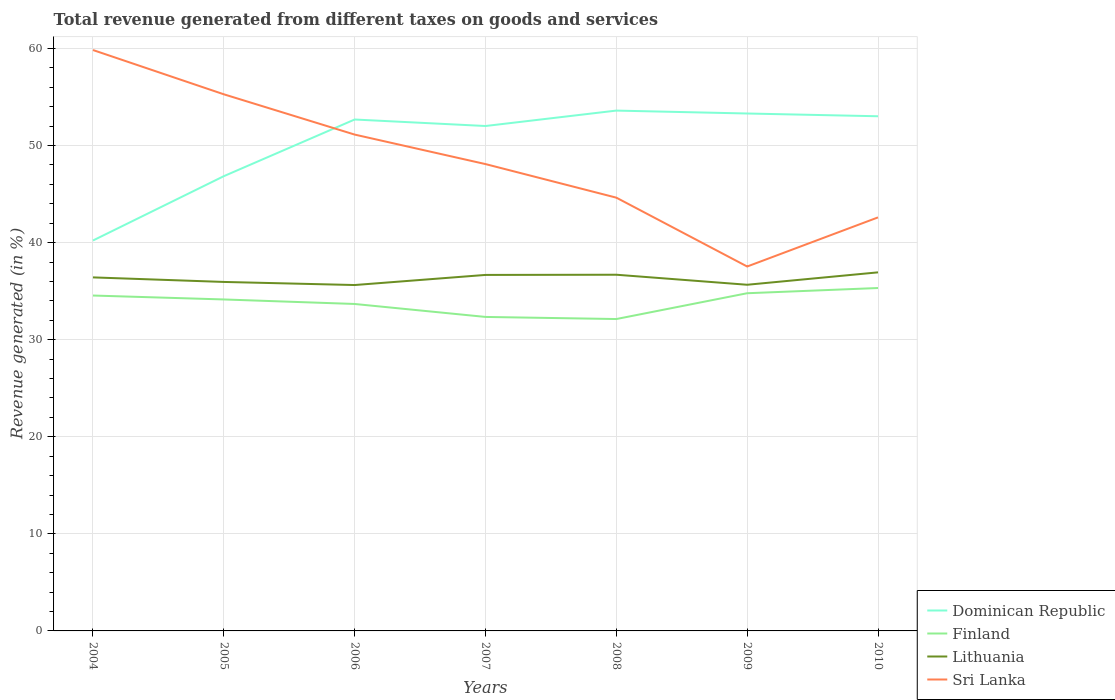How many different coloured lines are there?
Ensure brevity in your answer.  4. Does the line corresponding to Lithuania intersect with the line corresponding to Sri Lanka?
Your answer should be very brief. No. Is the number of lines equal to the number of legend labels?
Keep it short and to the point. Yes. Across all years, what is the maximum total revenue generated in Finland?
Make the answer very short. 32.13. In which year was the total revenue generated in Lithuania maximum?
Provide a succinct answer. 2006. What is the total total revenue generated in Sri Lanka in the graph?
Your response must be concise. 17.24. What is the difference between the highest and the second highest total revenue generated in Finland?
Your answer should be compact. 3.2. Is the total revenue generated in Lithuania strictly greater than the total revenue generated in Sri Lanka over the years?
Offer a terse response. Yes. How many lines are there?
Give a very brief answer. 4. How many years are there in the graph?
Offer a terse response. 7. What is the difference between two consecutive major ticks on the Y-axis?
Provide a succinct answer. 10. Are the values on the major ticks of Y-axis written in scientific E-notation?
Provide a succinct answer. No. Does the graph contain grids?
Your response must be concise. Yes. Where does the legend appear in the graph?
Your answer should be compact. Bottom right. How are the legend labels stacked?
Make the answer very short. Vertical. What is the title of the graph?
Your answer should be compact. Total revenue generated from different taxes on goods and services. What is the label or title of the Y-axis?
Give a very brief answer. Revenue generated (in %). What is the Revenue generated (in %) of Dominican Republic in 2004?
Give a very brief answer. 40.22. What is the Revenue generated (in %) of Finland in 2004?
Your answer should be very brief. 34.55. What is the Revenue generated (in %) in Lithuania in 2004?
Give a very brief answer. 36.42. What is the Revenue generated (in %) of Sri Lanka in 2004?
Offer a terse response. 59.84. What is the Revenue generated (in %) of Dominican Republic in 2005?
Give a very brief answer. 46.85. What is the Revenue generated (in %) of Finland in 2005?
Your response must be concise. 34.15. What is the Revenue generated (in %) of Lithuania in 2005?
Make the answer very short. 35.95. What is the Revenue generated (in %) in Sri Lanka in 2005?
Provide a short and direct response. 55.28. What is the Revenue generated (in %) of Dominican Republic in 2006?
Your answer should be compact. 52.68. What is the Revenue generated (in %) of Finland in 2006?
Your answer should be compact. 33.68. What is the Revenue generated (in %) of Lithuania in 2006?
Make the answer very short. 35.63. What is the Revenue generated (in %) of Sri Lanka in 2006?
Make the answer very short. 51.13. What is the Revenue generated (in %) in Dominican Republic in 2007?
Your response must be concise. 52.02. What is the Revenue generated (in %) in Finland in 2007?
Keep it short and to the point. 32.35. What is the Revenue generated (in %) in Lithuania in 2007?
Your response must be concise. 36.67. What is the Revenue generated (in %) in Sri Lanka in 2007?
Offer a very short reply. 48.09. What is the Revenue generated (in %) in Dominican Republic in 2008?
Offer a terse response. 53.6. What is the Revenue generated (in %) in Finland in 2008?
Your answer should be compact. 32.13. What is the Revenue generated (in %) in Lithuania in 2008?
Make the answer very short. 36.69. What is the Revenue generated (in %) of Sri Lanka in 2008?
Your answer should be compact. 44.63. What is the Revenue generated (in %) in Dominican Republic in 2009?
Give a very brief answer. 53.3. What is the Revenue generated (in %) of Finland in 2009?
Offer a very short reply. 34.79. What is the Revenue generated (in %) in Lithuania in 2009?
Make the answer very short. 35.66. What is the Revenue generated (in %) of Sri Lanka in 2009?
Make the answer very short. 37.54. What is the Revenue generated (in %) of Dominican Republic in 2010?
Ensure brevity in your answer.  53.02. What is the Revenue generated (in %) of Finland in 2010?
Your answer should be compact. 35.33. What is the Revenue generated (in %) of Lithuania in 2010?
Offer a very short reply. 36.94. What is the Revenue generated (in %) of Sri Lanka in 2010?
Your response must be concise. 42.6. Across all years, what is the maximum Revenue generated (in %) of Dominican Republic?
Provide a short and direct response. 53.6. Across all years, what is the maximum Revenue generated (in %) of Finland?
Your answer should be very brief. 35.33. Across all years, what is the maximum Revenue generated (in %) in Lithuania?
Provide a short and direct response. 36.94. Across all years, what is the maximum Revenue generated (in %) in Sri Lanka?
Give a very brief answer. 59.84. Across all years, what is the minimum Revenue generated (in %) of Dominican Republic?
Offer a very short reply. 40.22. Across all years, what is the minimum Revenue generated (in %) of Finland?
Your answer should be compact. 32.13. Across all years, what is the minimum Revenue generated (in %) of Lithuania?
Your response must be concise. 35.63. Across all years, what is the minimum Revenue generated (in %) in Sri Lanka?
Your answer should be very brief. 37.54. What is the total Revenue generated (in %) of Dominican Republic in the graph?
Provide a short and direct response. 351.69. What is the total Revenue generated (in %) of Finland in the graph?
Make the answer very short. 236.97. What is the total Revenue generated (in %) of Lithuania in the graph?
Give a very brief answer. 253.97. What is the total Revenue generated (in %) in Sri Lanka in the graph?
Offer a terse response. 339.13. What is the difference between the Revenue generated (in %) in Dominican Republic in 2004 and that in 2005?
Provide a short and direct response. -6.63. What is the difference between the Revenue generated (in %) in Finland in 2004 and that in 2005?
Offer a very short reply. 0.4. What is the difference between the Revenue generated (in %) in Lithuania in 2004 and that in 2005?
Your answer should be very brief. 0.47. What is the difference between the Revenue generated (in %) in Sri Lanka in 2004 and that in 2005?
Your answer should be compact. 4.56. What is the difference between the Revenue generated (in %) of Dominican Republic in 2004 and that in 2006?
Your answer should be very brief. -12.47. What is the difference between the Revenue generated (in %) of Finland in 2004 and that in 2006?
Your response must be concise. 0.87. What is the difference between the Revenue generated (in %) in Lithuania in 2004 and that in 2006?
Give a very brief answer. 0.79. What is the difference between the Revenue generated (in %) in Sri Lanka in 2004 and that in 2006?
Your response must be concise. 8.71. What is the difference between the Revenue generated (in %) in Dominican Republic in 2004 and that in 2007?
Offer a terse response. -11.8. What is the difference between the Revenue generated (in %) of Finland in 2004 and that in 2007?
Provide a succinct answer. 2.2. What is the difference between the Revenue generated (in %) in Lithuania in 2004 and that in 2007?
Offer a very short reply. -0.25. What is the difference between the Revenue generated (in %) of Sri Lanka in 2004 and that in 2007?
Provide a succinct answer. 11.75. What is the difference between the Revenue generated (in %) of Dominican Republic in 2004 and that in 2008?
Keep it short and to the point. -13.38. What is the difference between the Revenue generated (in %) in Finland in 2004 and that in 2008?
Your answer should be very brief. 2.42. What is the difference between the Revenue generated (in %) of Lithuania in 2004 and that in 2008?
Give a very brief answer. -0.27. What is the difference between the Revenue generated (in %) of Sri Lanka in 2004 and that in 2008?
Your response must be concise. 15.21. What is the difference between the Revenue generated (in %) of Dominican Republic in 2004 and that in 2009?
Make the answer very short. -13.08. What is the difference between the Revenue generated (in %) of Finland in 2004 and that in 2009?
Your answer should be very brief. -0.24. What is the difference between the Revenue generated (in %) in Lithuania in 2004 and that in 2009?
Your response must be concise. 0.76. What is the difference between the Revenue generated (in %) in Sri Lanka in 2004 and that in 2009?
Ensure brevity in your answer.  22.3. What is the difference between the Revenue generated (in %) of Finland in 2004 and that in 2010?
Provide a succinct answer. -0.78. What is the difference between the Revenue generated (in %) in Lithuania in 2004 and that in 2010?
Ensure brevity in your answer.  -0.52. What is the difference between the Revenue generated (in %) in Sri Lanka in 2004 and that in 2010?
Your answer should be very brief. 17.24. What is the difference between the Revenue generated (in %) in Dominican Republic in 2005 and that in 2006?
Offer a terse response. -5.84. What is the difference between the Revenue generated (in %) in Finland in 2005 and that in 2006?
Provide a short and direct response. 0.47. What is the difference between the Revenue generated (in %) in Lithuania in 2005 and that in 2006?
Your response must be concise. 0.32. What is the difference between the Revenue generated (in %) of Sri Lanka in 2005 and that in 2006?
Ensure brevity in your answer.  4.15. What is the difference between the Revenue generated (in %) of Dominican Republic in 2005 and that in 2007?
Your answer should be compact. -5.17. What is the difference between the Revenue generated (in %) in Finland in 2005 and that in 2007?
Your answer should be very brief. 1.8. What is the difference between the Revenue generated (in %) of Lithuania in 2005 and that in 2007?
Make the answer very short. -0.72. What is the difference between the Revenue generated (in %) of Sri Lanka in 2005 and that in 2007?
Your response must be concise. 7.19. What is the difference between the Revenue generated (in %) of Dominican Republic in 2005 and that in 2008?
Your response must be concise. -6.76. What is the difference between the Revenue generated (in %) in Finland in 2005 and that in 2008?
Ensure brevity in your answer.  2.02. What is the difference between the Revenue generated (in %) in Lithuania in 2005 and that in 2008?
Offer a terse response. -0.74. What is the difference between the Revenue generated (in %) of Sri Lanka in 2005 and that in 2008?
Offer a terse response. 10.65. What is the difference between the Revenue generated (in %) in Dominican Republic in 2005 and that in 2009?
Make the answer very short. -6.46. What is the difference between the Revenue generated (in %) of Finland in 2005 and that in 2009?
Offer a very short reply. -0.64. What is the difference between the Revenue generated (in %) in Lithuania in 2005 and that in 2009?
Keep it short and to the point. 0.29. What is the difference between the Revenue generated (in %) of Sri Lanka in 2005 and that in 2009?
Offer a terse response. 17.74. What is the difference between the Revenue generated (in %) of Dominican Republic in 2005 and that in 2010?
Provide a short and direct response. -6.17. What is the difference between the Revenue generated (in %) of Finland in 2005 and that in 2010?
Make the answer very short. -1.18. What is the difference between the Revenue generated (in %) in Lithuania in 2005 and that in 2010?
Your response must be concise. -0.99. What is the difference between the Revenue generated (in %) in Sri Lanka in 2005 and that in 2010?
Offer a very short reply. 12.68. What is the difference between the Revenue generated (in %) of Dominican Republic in 2006 and that in 2007?
Give a very brief answer. 0.67. What is the difference between the Revenue generated (in %) in Finland in 2006 and that in 2007?
Offer a terse response. 1.33. What is the difference between the Revenue generated (in %) of Lithuania in 2006 and that in 2007?
Offer a terse response. -1.04. What is the difference between the Revenue generated (in %) of Sri Lanka in 2006 and that in 2007?
Offer a very short reply. 3.04. What is the difference between the Revenue generated (in %) in Dominican Republic in 2006 and that in 2008?
Give a very brief answer. -0.92. What is the difference between the Revenue generated (in %) of Finland in 2006 and that in 2008?
Your response must be concise. 1.55. What is the difference between the Revenue generated (in %) of Lithuania in 2006 and that in 2008?
Your response must be concise. -1.06. What is the difference between the Revenue generated (in %) of Sri Lanka in 2006 and that in 2008?
Offer a terse response. 6.5. What is the difference between the Revenue generated (in %) of Dominican Republic in 2006 and that in 2009?
Give a very brief answer. -0.62. What is the difference between the Revenue generated (in %) in Finland in 2006 and that in 2009?
Provide a succinct answer. -1.11. What is the difference between the Revenue generated (in %) of Lithuania in 2006 and that in 2009?
Your response must be concise. -0.03. What is the difference between the Revenue generated (in %) in Sri Lanka in 2006 and that in 2009?
Ensure brevity in your answer.  13.59. What is the difference between the Revenue generated (in %) of Dominican Republic in 2006 and that in 2010?
Provide a succinct answer. -0.33. What is the difference between the Revenue generated (in %) of Finland in 2006 and that in 2010?
Your answer should be compact. -1.64. What is the difference between the Revenue generated (in %) in Lithuania in 2006 and that in 2010?
Offer a terse response. -1.31. What is the difference between the Revenue generated (in %) of Sri Lanka in 2006 and that in 2010?
Keep it short and to the point. 8.53. What is the difference between the Revenue generated (in %) in Dominican Republic in 2007 and that in 2008?
Ensure brevity in your answer.  -1.59. What is the difference between the Revenue generated (in %) in Finland in 2007 and that in 2008?
Ensure brevity in your answer.  0.22. What is the difference between the Revenue generated (in %) in Lithuania in 2007 and that in 2008?
Your response must be concise. -0.02. What is the difference between the Revenue generated (in %) of Sri Lanka in 2007 and that in 2008?
Make the answer very short. 3.46. What is the difference between the Revenue generated (in %) in Dominican Republic in 2007 and that in 2009?
Make the answer very short. -1.29. What is the difference between the Revenue generated (in %) of Finland in 2007 and that in 2009?
Your response must be concise. -2.44. What is the difference between the Revenue generated (in %) in Lithuania in 2007 and that in 2009?
Make the answer very short. 1.01. What is the difference between the Revenue generated (in %) of Sri Lanka in 2007 and that in 2009?
Provide a succinct answer. 10.55. What is the difference between the Revenue generated (in %) of Dominican Republic in 2007 and that in 2010?
Provide a succinct answer. -1. What is the difference between the Revenue generated (in %) in Finland in 2007 and that in 2010?
Offer a very short reply. -2.98. What is the difference between the Revenue generated (in %) in Lithuania in 2007 and that in 2010?
Your response must be concise. -0.26. What is the difference between the Revenue generated (in %) of Sri Lanka in 2007 and that in 2010?
Ensure brevity in your answer.  5.49. What is the difference between the Revenue generated (in %) of Dominican Republic in 2008 and that in 2009?
Offer a terse response. 0.3. What is the difference between the Revenue generated (in %) of Finland in 2008 and that in 2009?
Give a very brief answer. -2.66. What is the difference between the Revenue generated (in %) of Lithuania in 2008 and that in 2009?
Your response must be concise. 1.03. What is the difference between the Revenue generated (in %) in Sri Lanka in 2008 and that in 2009?
Offer a very short reply. 7.09. What is the difference between the Revenue generated (in %) of Dominican Republic in 2008 and that in 2010?
Your response must be concise. 0.58. What is the difference between the Revenue generated (in %) in Finland in 2008 and that in 2010?
Offer a very short reply. -3.2. What is the difference between the Revenue generated (in %) in Lithuania in 2008 and that in 2010?
Ensure brevity in your answer.  -0.24. What is the difference between the Revenue generated (in %) of Sri Lanka in 2008 and that in 2010?
Your response must be concise. 2.03. What is the difference between the Revenue generated (in %) in Dominican Republic in 2009 and that in 2010?
Provide a short and direct response. 0.28. What is the difference between the Revenue generated (in %) of Finland in 2009 and that in 2010?
Provide a succinct answer. -0.54. What is the difference between the Revenue generated (in %) in Lithuania in 2009 and that in 2010?
Ensure brevity in your answer.  -1.28. What is the difference between the Revenue generated (in %) in Sri Lanka in 2009 and that in 2010?
Provide a short and direct response. -5.06. What is the difference between the Revenue generated (in %) in Dominican Republic in 2004 and the Revenue generated (in %) in Finland in 2005?
Keep it short and to the point. 6.07. What is the difference between the Revenue generated (in %) in Dominican Republic in 2004 and the Revenue generated (in %) in Lithuania in 2005?
Provide a short and direct response. 4.27. What is the difference between the Revenue generated (in %) in Dominican Republic in 2004 and the Revenue generated (in %) in Sri Lanka in 2005?
Your answer should be very brief. -15.06. What is the difference between the Revenue generated (in %) in Finland in 2004 and the Revenue generated (in %) in Lithuania in 2005?
Keep it short and to the point. -1.4. What is the difference between the Revenue generated (in %) of Finland in 2004 and the Revenue generated (in %) of Sri Lanka in 2005?
Your answer should be compact. -20.73. What is the difference between the Revenue generated (in %) of Lithuania in 2004 and the Revenue generated (in %) of Sri Lanka in 2005?
Offer a terse response. -18.86. What is the difference between the Revenue generated (in %) of Dominican Republic in 2004 and the Revenue generated (in %) of Finland in 2006?
Make the answer very short. 6.54. What is the difference between the Revenue generated (in %) in Dominican Republic in 2004 and the Revenue generated (in %) in Lithuania in 2006?
Provide a short and direct response. 4.59. What is the difference between the Revenue generated (in %) of Dominican Republic in 2004 and the Revenue generated (in %) of Sri Lanka in 2006?
Provide a succinct answer. -10.91. What is the difference between the Revenue generated (in %) in Finland in 2004 and the Revenue generated (in %) in Lithuania in 2006?
Keep it short and to the point. -1.08. What is the difference between the Revenue generated (in %) in Finland in 2004 and the Revenue generated (in %) in Sri Lanka in 2006?
Provide a short and direct response. -16.58. What is the difference between the Revenue generated (in %) of Lithuania in 2004 and the Revenue generated (in %) of Sri Lanka in 2006?
Keep it short and to the point. -14.71. What is the difference between the Revenue generated (in %) in Dominican Republic in 2004 and the Revenue generated (in %) in Finland in 2007?
Your response must be concise. 7.87. What is the difference between the Revenue generated (in %) of Dominican Republic in 2004 and the Revenue generated (in %) of Lithuania in 2007?
Offer a terse response. 3.54. What is the difference between the Revenue generated (in %) of Dominican Republic in 2004 and the Revenue generated (in %) of Sri Lanka in 2007?
Ensure brevity in your answer.  -7.87. What is the difference between the Revenue generated (in %) in Finland in 2004 and the Revenue generated (in %) in Lithuania in 2007?
Provide a short and direct response. -2.12. What is the difference between the Revenue generated (in %) of Finland in 2004 and the Revenue generated (in %) of Sri Lanka in 2007?
Your response must be concise. -13.54. What is the difference between the Revenue generated (in %) in Lithuania in 2004 and the Revenue generated (in %) in Sri Lanka in 2007?
Your answer should be very brief. -11.67. What is the difference between the Revenue generated (in %) of Dominican Republic in 2004 and the Revenue generated (in %) of Finland in 2008?
Your response must be concise. 8.09. What is the difference between the Revenue generated (in %) of Dominican Republic in 2004 and the Revenue generated (in %) of Lithuania in 2008?
Keep it short and to the point. 3.53. What is the difference between the Revenue generated (in %) in Dominican Republic in 2004 and the Revenue generated (in %) in Sri Lanka in 2008?
Give a very brief answer. -4.42. What is the difference between the Revenue generated (in %) of Finland in 2004 and the Revenue generated (in %) of Lithuania in 2008?
Your response must be concise. -2.14. What is the difference between the Revenue generated (in %) of Finland in 2004 and the Revenue generated (in %) of Sri Lanka in 2008?
Offer a terse response. -10.08. What is the difference between the Revenue generated (in %) in Lithuania in 2004 and the Revenue generated (in %) in Sri Lanka in 2008?
Your answer should be very brief. -8.21. What is the difference between the Revenue generated (in %) of Dominican Republic in 2004 and the Revenue generated (in %) of Finland in 2009?
Your response must be concise. 5.43. What is the difference between the Revenue generated (in %) in Dominican Republic in 2004 and the Revenue generated (in %) in Lithuania in 2009?
Make the answer very short. 4.56. What is the difference between the Revenue generated (in %) in Dominican Republic in 2004 and the Revenue generated (in %) in Sri Lanka in 2009?
Your answer should be compact. 2.68. What is the difference between the Revenue generated (in %) in Finland in 2004 and the Revenue generated (in %) in Lithuania in 2009?
Offer a terse response. -1.11. What is the difference between the Revenue generated (in %) of Finland in 2004 and the Revenue generated (in %) of Sri Lanka in 2009?
Make the answer very short. -2.99. What is the difference between the Revenue generated (in %) of Lithuania in 2004 and the Revenue generated (in %) of Sri Lanka in 2009?
Offer a terse response. -1.12. What is the difference between the Revenue generated (in %) of Dominican Republic in 2004 and the Revenue generated (in %) of Finland in 2010?
Your answer should be very brief. 4.89. What is the difference between the Revenue generated (in %) of Dominican Republic in 2004 and the Revenue generated (in %) of Lithuania in 2010?
Keep it short and to the point. 3.28. What is the difference between the Revenue generated (in %) of Dominican Republic in 2004 and the Revenue generated (in %) of Sri Lanka in 2010?
Offer a very short reply. -2.38. What is the difference between the Revenue generated (in %) in Finland in 2004 and the Revenue generated (in %) in Lithuania in 2010?
Offer a terse response. -2.39. What is the difference between the Revenue generated (in %) of Finland in 2004 and the Revenue generated (in %) of Sri Lanka in 2010?
Keep it short and to the point. -8.05. What is the difference between the Revenue generated (in %) in Lithuania in 2004 and the Revenue generated (in %) in Sri Lanka in 2010?
Your response must be concise. -6.18. What is the difference between the Revenue generated (in %) of Dominican Republic in 2005 and the Revenue generated (in %) of Finland in 2006?
Provide a succinct answer. 13.17. What is the difference between the Revenue generated (in %) in Dominican Republic in 2005 and the Revenue generated (in %) in Lithuania in 2006?
Your answer should be compact. 11.21. What is the difference between the Revenue generated (in %) of Dominican Republic in 2005 and the Revenue generated (in %) of Sri Lanka in 2006?
Your response must be concise. -4.29. What is the difference between the Revenue generated (in %) in Finland in 2005 and the Revenue generated (in %) in Lithuania in 2006?
Offer a very short reply. -1.49. What is the difference between the Revenue generated (in %) in Finland in 2005 and the Revenue generated (in %) in Sri Lanka in 2006?
Provide a succinct answer. -16.98. What is the difference between the Revenue generated (in %) of Lithuania in 2005 and the Revenue generated (in %) of Sri Lanka in 2006?
Your answer should be very brief. -15.18. What is the difference between the Revenue generated (in %) of Dominican Republic in 2005 and the Revenue generated (in %) of Finland in 2007?
Provide a short and direct response. 14.5. What is the difference between the Revenue generated (in %) in Dominican Republic in 2005 and the Revenue generated (in %) in Lithuania in 2007?
Offer a very short reply. 10.17. What is the difference between the Revenue generated (in %) in Dominican Republic in 2005 and the Revenue generated (in %) in Sri Lanka in 2007?
Make the answer very short. -1.25. What is the difference between the Revenue generated (in %) of Finland in 2005 and the Revenue generated (in %) of Lithuania in 2007?
Provide a succinct answer. -2.53. What is the difference between the Revenue generated (in %) in Finland in 2005 and the Revenue generated (in %) in Sri Lanka in 2007?
Your response must be concise. -13.94. What is the difference between the Revenue generated (in %) of Lithuania in 2005 and the Revenue generated (in %) of Sri Lanka in 2007?
Your response must be concise. -12.14. What is the difference between the Revenue generated (in %) in Dominican Republic in 2005 and the Revenue generated (in %) in Finland in 2008?
Keep it short and to the point. 14.72. What is the difference between the Revenue generated (in %) in Dominican Republic in 2005 and the Revenue generated (in %) in Lithuania in 2008?
Provide a short and direct response. 10.15. What is the difference between the Revenue generated (in %) in Dominican Republic in 2005 and the Revenue generated (in %) in Sri Lanka in 2008?
Offer a very short reply. 2.21. What is the difference between the Revenue generated (in %) of Finland in 2005 and the Revenue generated (in %) of Lithuania in 2008?
Give a very brief answer. -2.55. What is the difference between the Revenue generated (in %) of Finland in 2005 and the Revenue generated (in %) of Sri Lanka in 2008?
Your answer should be compact. -10.49. What is the difference between the Revenue generated (in %) of Lithuania in 2005 and the Revenue generated (in %) of Sri Lanka in 2008?
Give a very brief answer. -8.68. What is the difference between the Revenue generated (in %) of Dominican Republic in 2005 and the Revenue generated (in %) of Finland in 2009?
Provide a succinct answer. 12.06. What is the difference between the Revenue generated (in %) of Dominican Republic in 2005 and the Revenue generated (in %) of Lithuania in 2009?
Your answer should be very brief. 11.19. What is the difference between the Revenue generated (in %) in Dominican Republic in 2005 and the Revenue generated (in %) in Sri Lanka in 2009?
Keep it short and to the point. 9.31. What is the difference between the Revenue generated (in %) in Finland in 2005 and the Revenue generated (in %) in Lithuania in 2009?
Your response must be concise. -1.51. What is the difference between the Revenue generated (in %) in Finland in 2005 and the Revenue generated (in %) in Sri Lanka in 2009?
Your answer should be very brief. -3.39. What is the difference between the Revenue generated (in %) of Lithuania in 2005 and the Revenue generated (in %) of Sri Lanka in 2009?
Provide a short and direct response. -1.59. What is the difference between the Revenue generated (in %) of Dominican Republic in 2005 and the Revenue generated (in %) of Finland in 2010?
Your response must be concise. 11.52. What is the difference between the Revenue generated (in %) in Dominican Republic in 2005 and the Revenue generated (in %) in Lithuania in 2010?
Provide a short and direct response. 9.91. What is the difference between the Revenue generated (in %) of Dominican Republic in 2005 and the Revenue generated (in %) of Sri Lanka in 2010?
Your answer should be compact. 4.25. What is the difference between the Revenue generated (in %) in Finland in 2005 and the Revenue generated (in %) in Lithuania in 2010?
Your response must be concise. -2.79. What is the difference between the Revenue generated (in %) in Finland in 2005 and the Revenue generated (in %) in Sri Lanka in 2010?
Your answer should be compact. -8.45. What is the difference between the Revenue generated (in %) in Lithuania in 2005 and the Revenue generated (in %) in Sri Lanka in 2010?
Your response must be concise. -6.65. What is the difference between the Revenue generated (in %) of Dominican Republic in 2006 and the Revenue generated (in %) of Finland in 2007?
Your response must be concise. 20.34. What is the difference between the Revenue generated (in %) in Dominican Republic in 2006 and the Revenue generated (in %) in Lithuania in 2007?
Ensure brevity in your answer.  16.01. What is the difference between the Revenue generated (in %) in Dominican Republic in 2006 and the Revenue generated (in %) in Sri Lanka in 2007?
Offer a very short reply. 4.59. What is the difference between the Revenue generated (in %) of Finland in 2006 and the Revenue generated (in %) of Lithuania in 2007?
Give a very brief answer. -2.99. What is the difference between the Revenue generated (in %) in Finland in 2006 and the Revenue generated (in %) in Sri Lanka in 2007?
Offer a very short reply. -14.41. What is the difference between the Revenue generated (in %) of Lithuania in 2006 and the Revenue generated (in %) of Sri Lanka in 2007?
Offer a terse response. -12.46. What is the difference between the Revenue generated (in %) of Dominican Republic in 2006 and the Revenue generated (in %) of Finland in 2008?
Your response must be concise. 20.55. What is the difference between the Revenue generated (in %) in Dominican Republic in 2006 and the Revenue generated (in %) in Lithuania in 2008?
Ensure brevity in your answer.  15.99. What is the difference between the Revenue generated (in %) in Dominican Republic in 2006 and the Revenue generated (in %) in Sri Lanka in 2008?
Provide a short and direct response. 8.05. What is the difference between the Revenue generated (in %) in Finland in 2006 and the Revenue generated (in %) in Lithuania in 2008?
Provide a short and direct response. -3.01. What is the difference between the Revenue generated (in %) of Finland in 2006 and the Revenue generated (in %) of Sri Lanka in 2008?
Your answer should be very brief. -10.95. What is the difference between the Revenue generated (in %) of Lithuania in 2006 and the Revenue generated (in %) of Sri Lanka in 2008?
Your answer should be very brief. -9. What is the difference between the Revenue generated (in %) of Dominican Republic in 2006 and the Revenue generated (in %) of Finland in 2009?
Your response must be concise. 17.9. What is the difference between the Revenue generated (in %) in Dominican Republic in 2006 and the Revenue generated (in %) in Lithuania in 2009?
Your answer should be very brief. 17.02. What is the difference between the Revenue generated (in %) in Dominican Republic in 2006 and the Revenue generated (in %) in Sri Lanka in 2009?
Ensure brevity in your answer.  15.14. What is the difference between the Revenue generated (in %) in Finland in 2006 and the Revenue generated (in %) in Lithuania in 2009?
Offer a very short reply. -1.98. What is the difference between the Revenue generated (in %) in Finland in 2006 and the Revenue generated (in %) in Sri Lanka in 2009?
Ensure brevity in your answer.  -3.86. What is the difference between the Revenue generated (in %) in Lithuania in 2006 and the Revenue generated (in %) in Sri Lanka in 2009?
Provide a short and direct response. -1.91. What is the difference between the Revenue generated (in %) of Dominican Republic in 2006 and the Revenue generated (in %) of Finland in 2010?
Your answer should be compact. 17.36. What is the difference between the Revenue generated (in %) of Dominican Republic in 2006 and the Revenue generated (in %) of Lithuania in 2010?
Offer a very short reply. 15.75. What is the difference between the Revenue generated (in %) of Dominican Republic in 2006 and the Revenue generated (in %) of Sri Lanka in 2010?
Offer a terse response. 10.08. What is the difference between the Revenue generated (in %) of Finland in 2006 and the Revenue generated (in %) of Lithuania in 2010?
Your answer should be compact. -3.26. What is the difference between the Revenue generated (in %) in Finland in 2006 and the Revenue generated (in %) in Sri Lanka in 2010?
Offer a very short reply. -8.92. What is the difference between the Revenue generated (in %) in Lithuania in 2006 and the Revenue generated (in %) in Sri Lanka in 2010?
Offer a terse response. -6.97. What is the difference between the Revenue generated (in %) of Dominican Republic in 2007 and the Revenue generated (in %) of Finland in 2008?
Offer a terse response. 19.88. What is the difference between the Revenue generated (in %) in Dominican Republic in 2007 and the Revenue generated (in %) in Lithuania in 2008?
Ensure brevity in your answer.  15.32. What is the difference between the Revenue generated (in %) of Dominican Republic in 2007 and the Revenue generated (in %) of Sri Lanka in 2008?
Provide a succinct answer. 7.38. What is the difference between the Revenue generated (in %) in Finland in 2007 and the Revenue generated (in %) in Lithuania in 2008?
Offer a very short reply. -4.35. What is the difference between the Revenue generated (in %) of Finland in 2007 and the Revenue generated (in %) of Sri Lanka in 2008?
Your response must be concise. -12.29. What is the difference between the Revenue generated (in %) in Lithuania in 2007 and the Revenue generated (in %) in Sri Lanka in 2008?
Ensure brevity in your answer.  -7.96. What is the difference between the Revenue generated (in %) of Dominican Republic in 2007 and the Revenue generated (in %) of Finland in 2009?
Ensure brevity in your answer.  17.23. What is the difference between the Revenue generated (in %) in Dominican Republic in 2007 and the Revenue generated (in %) in Lithuania in 2009?
Offer a very short reply. 16.35. What is the difference between the Revenue generated (in %) in Dominican Republic in 2007 and the Revenue generated (in %) in Sri Lanka in 2009?
Your response must be concise. 14.47. What is the difference between the Revenue generated (in %) of Finland in 2007 and the Revenue generated (in %) of Lithuania in 2009?
Provide a succinct answer. -3.31. What is the difference between the Revenue generated (in %) of Finland in 2007 and the Revenue generated (in %) of Sri Lanka in 2009?
Give a very brief answer. -5.19. What is the difference between the Revenue generated (in %) in Lithuania in 2007 and the Revenue generated (in %) in Sri Lanka in 2009?
Provide a succinct answer. -0.87. What is the difference between the Revenue generated (in %) in Dominican Republic in 2007 and the Revenue generated (in %) in Finland in 2010?
Make the answer very short. 16.69. What is the difference between the Revenue generated (in %) of Dominican Republic in 2007 and the Revenue generated (in %) of Lithuania in 2010?
Give a very brief answer. 15.08. What is the difference between the Revenue generated (in %) in Dominican Republic in 2007 and the Revenue generated (in %) in Sri Lanka in 2010?
Give a very brief answer. 9.41. What is the difference between the Revenue generated (in %) in Finland in 2007 and the Revenue generated (in %) in Lithuania in 2010?
Your answer should be compact. -4.59. What is the difference between the Revenue generated (in %) of Finland in 2007 and the Revenue generated (in %) of Sri Lanka in 2010?
Offer a terse response. -10.25. What is the difference between the Revenue generated (in %) of Lithuania in 2007 and the Revenue generated (in %) of Sri Lanka in 2010?
Your answer should be very brief. -5.93. What is the difference between the Revenue generated (in %) in Dominican Republic in 2008 and the Revenue generated (in %) in Finland in 2009?
Ensure brevity in your answer.  18.82. What is the difference between the Revenue generated (in %) in Dominican Republic in 2008 and the Revenue generated (in %) in Lithuania in 2009?
Give a very brief answer. 17.94. What is the difference between the Revenue generated (in %) of Dominican Republic in 2008 and the Revenue generated (in %) of Sri Lanka in 2009?
Your answer should be compact. 16.06. What is the difference between the Revenue generated (in %) in Finland in 2008 and the Revenue generated (in %) in Lithuania in 2009?
Your answer should be very brief. -3.53. What is the difference between the Revenue generated (in %) in Finland in 2008 and the Revenue generated (in %) in Sri Lanka in 2009?
Give a very brief answer. -5.41. What is the difference between the Revenue generated (in %) in Lithuania in 2008 and the Revenue generated (in %) in Sri Lanka in 2009?
Make the answer very short. -0.85. What is the difference between the Revenue generated (in %) of Dominican Republic in 2008 and the Revenue generated (in %) of Finland in 2010?
Make the answer very short. 18.28. What is the difference between the Revenue generated (in %) in Dominican Republic in 2008 and the Revenue generated (in %) in Lithuania in 2010?
Your answer should be very brief. 16.66. What is the difference between the Revenue generated (in %) of Dominican Republic in 2008 and the Revenue generated (in %) of Sri Lanka in 2010?
Make the answer very short. 11. What is the difference between the Revenue generated (in %) of Finland in 2008 and the Revenue generated (in %) of Lithuania in 2010?
Offer a terse response. -4.81. What is the difference between the Revenue generated (in %) of Finland in 2008 and the Revenue generated (in %) of Sri Lanka in 2010?
Make the answer very short. -10.47. What is the difference between the Revenue generated (in %) in Lithuania in 2008 and the Revenue generated (in %) in Sri Lanka in 2010?
Provide a succinct answer. -5.91. What is the difference between the Revenue generated (in %) in Dominican Republic in 2009 and the Revenue generated (in %) in Finland in 2010?
Your answer should be very brief. 17.98. What is the difference between the Revenue generated (in %) of Dominican Republic in 2009 and the Revenue generated (in %) of Lithuania in 2010?
Your response must be concise. 16.36. What is the difference between the Revenue generated (in %) of Dominican Republic in 2009 and the Revenue generated (in %) of Sri Lanka in 2010?
Make the answer very short. 10.7. What is the difference between the Revenue generated (in %) in Finland in 2009 and the Revenue generated (in %) in Lithuania in 2010?
Your answer should be very brief. -2.15. What is the difference between the Revenue generated (in %) of Finland in 2009 and the Revenue generated (in %) of Sri Lanka in 2010?
Offer a terse response. -7.81. What is the difference between the Revenue generated (in %) of Lithuania in 2009 and the Revenue generated (in %) of Sri Lanka in 2010?
Make the answer very short. -6.94. What is the average Revenue generated (in %) of Dominican Republic per year?
Offer a terse response. 50.24. What is the average Revenue generated (in %) in Finland per year?
Provide a succinct answer. 33.85. What is the average Revenue generated (in %) of Lithuania per year?
Provide a short and direct response. 36.28. What is the average Revenue generated (in %) in Sri Lanka per year?
Provide a succinct answer. 48.45. In the year 2004, what is the difference between the Revenue generated (in %) of Dominican Republic and Revenue generated (in %) of Finland?
Your answer should be very brief. 5.67. In the year 2004, what is the difference between the Revenue generated (in %) in Dominican Republic and Revenue generated (in %) in Lithuania?
Keep it short and to the point. 3.8. In the year 2004, what is the difference between the Revenue generated (in %) of Dominican Republic and Revenue generated (in %) of Sri Lanka?
Give a very brief answer. -19.62. In the year 2004, what is the difference between the Revenue generated (in %) of Finland and Revenue generated (in %) of Lithuania?
Your response must be concise. -1.87. In the year 2004, what is the difference between the Revenue generated (in %) of Finland and Revenue generated (in %) of Sri Lanka?
Offer a terse response. -25.29. In the year 2004, what is the difference between the Revenue generated (in %) in Lithuania and Revenue generated (in %) in Sri Lanka?
Provide a short and direct response. -23.42. In the year 2005, what is the difference between the Revenue generated (in %) in Dominican Republic and Revenue generated (in %) in Finland?
Keep it short and to the point. 12.7. In the year 2005, what is the difference between the Revenue generated (in %) of Dominican Republic and Revenue generated (in %) of Lithuania?
Provide a succinct answer. 10.89. In the year 2005, what is the difference between the Revenue generated (in %) in Dominican Republic and Revenue generated (in %) in Sri Lanka?
Provide a succinct answer. -8.44. In the year 2005, what is the difference between the Revenue generated (in %) of Finland and Revenue generated (in %) of Lithuania?
Ensure brevity in your answer.  -1.8. In the year 2005, what is the difference between the Revenue generated (in %) in Finland and Revenue generated (in %) in Sri Lanka?
Your answer should be compact. -21.14. In the year 2005, what is the difference between the Revenue generated (in %) of Lithuania and Revenue generated (in %) of Sri Lanka?
Keep it short and to the point. -19.33. In the year 2006, what is the difference between the Revenue generated (in %) of Dominican Republic and Revenue generated (in %) of Finland?
Provide a succinct answer. 19. In the year 2006, what is the difference between the Revenue generated (in %) in Dominican Republic and Revenue generated (in %) in Lithuania?
Keep it short and to the point. 17.05. In the year 2006, what is the difference between the Revenue generated (in %) of Dominican Republic and Revenue generated (in %) of Sri Lanka?
Provide a short and direct response. 1.55. In the year 2006, what is the difference between the Revenue generated (in %) in Finland and Revenue generated (in %) in Lithuania?
Provide a short and direct response. -1.95. In the year 2006, what is the difference between the Revenue generated (in %) in Finland and Revenue generated (in %) in Sri Lanka?
Ensure brevity in your answer.  -17.45. In the year 2006, what is the difference between the Revenue generated (in %) of Lithuania and Revenue generated (in %) of Sri Lanka?
Your answer should be compact. -15.5. In the year 2007, what is the difference between the Revenue generated (in %) in Dominican Republic and Revenue generated (in %) in Finland?
Make the answer very short. 19.67. In the year 2007, what is the difference between the Revenue generated (in %) of Dominican Republic and Revenue generated (in %) of Lithuania?
Provide a short and direct response. 15.34. In the year 2007, what is the difference between the Revenue generated (in %) in Dominican Republic and Revenue generated (in %) in Sri Lanka?
Your response must be concise. 3.92. In the year 2007, what is the difference between the Revenue generated (in %) of Finland and Revenue generated (in %) of Lithuania?
Your response must be concise. -4.33. In the year 2007, what is the difference between the Revenue generated (in %) in Finland and Revenue generated (in %) in Sri Lanka?
Your response must be concise. -15.75. In the year 2007, what is the difference between the Revenue generated (in %) in Lithuania and Revenue generated (in %) in Sri Lanka?
Give a very brief answer. -11.42. In the year 2008, what is the difference between the Revenue generated (in %) in Dominican Republic and Revenue generated (in %) in Finland?
Give a very brief answer. 21.47. In the year 2008, what is the difference between the Revenue generated (in %) in Dominican Republic and Revenue generated (in %) in Lithuania?
Your answer should be compact. 16.91. In the year 2008, what is the difference between the Revenue generated (in %) of Dominican Republic and Revenue generated (in %) of Sri Lanka?
Your response must be concise. 8.97. In the year 2008, what is the difference between the Revenue generated (in %) of Finland and Revenue generated (in %) of Lithuania?
Your answer should be very brief. -4.56. In the year 2008, what is the difference between the Revenue generated (in %) of Finland and Revenue generated (in %) of Sri Lanka?
Make the answer very short. -12.5. In the year 2008, what is the difference between the Revenue generated (in %) of Lithuania and Revenue generated (in %) of Sri Lanka?
Keep it short and to the point. -7.94. In the year 2009, what is the difference between the Revenue generated (in %) of Dominican Republic and Revenue generated (in %) of Finland?
Provide a succinct answer. 18.51. In the year 2009, what is the difference between the Revenue generated (in %) in Dominican Republic and Revenue generated (in %) in Lithuania?
Offer a very short reply. 17.64. In the year 2009, what is the difference between the Revenue generated (in %) in Dominican Republic and Revenue generated (in %) in Sri Lanka?
Offer a very short reply. 15.76. In the year 2009, what is the difference between the Revenue generated (in %) of Finland and Revenue generated (in %) of Lithuania?
Give a very brief answer. -0.87. In the year 2009, what is the difference between the Revenue generated (in %) in Finland and Revenue generated (in %) in Sri Lanka?
Your response must be concise. -2.75. In the year 2009, what is the difference between the Revenue generated (in %) in Lithuania and Revenue generated (in %) in Sri Lanka?
Give a very brief answer. -1.88. In the year 2010, what is the difference between the Revenue generated (in %) in Dominican Republic and Revenue generated (in %) in Finland?
Ensure brevity in your answer.  17.69. In the year 2010, what is the difference between the Revenue generated (in %) of Dominican Republic and Revenue generated (in %) of Lithuania?
Provide a short and direct response. 16.08. In the year 2010, what is the difference between the Revenue generated (in %) in Dominican Republic and Revenue generated (in %) in Sri Lanka?
Offer a terse response. 10.42. In the year 2010, what is the difference between the Revenue generated (in %) of Finland and Revenue generated (in %) of Lithuania?
Keep it short and to the point. -1.61. In the year 2010, what is the difference between the Revenue generated (in %) in Finland and Revenue generated (in %) in Sri Lanka?
Your response must be concise. -7.27. In the year 2010, what is the difference between the Revenue generated (in %) of Lithuania and Revenue generated (in %) of Sri Lanka?
Provide a succinct answer. -5.66. What is the ratio of the Revenue generated (in %) in Dominican Republic in 2004 to that in 2005?
Ensure brevity in your answer.  0.86. What is the ratio of the Revenue generated (in %) of Finland in 2004 to that in 2005?
Give a very brief answer. 1.01. What is the ratio of the Revenue generated (in %) of Sri Lanka in 2004 to that in 2005?
Your answer should be very brief. 1.08. What is the ratio of the Revenue generated (in %) of Dominican Republic in 2004 to that in 2006?
Offer a very short reply. 0.76. What is the ratio of the Revenue generated (in %) of Finland in 2004 to that in 2006?
Provide a succinct answer. 1.03. What is the ratio of the Revenue generated (in %) in Lithuania in 2004 to that in 2006?
Your answer should be very brief. 1.02. What is the ratio of the Revenue generated (in %) of Sri Lanka in 2004 to that in 2006?
Your answer should be very brief. 1.17. What is the ratio of the Revenue generated (in %) of Dominican Republic in 2004 to that in 2007?
Ensure brevity in your answer.  0.77. What is the ratio of the Revenue generated (in %) in Finland in 2004 to that in 2007?
Give a very brief answer. 1.07. What is the ratio of the Revenue generated (in %) of Lithuania in 2004 to that in 2007?
Provide a short and direct response. 0.99. What is the ratio of the Revenue generated (in %) in Sri Lanka in 2004 to that in 2007?
Provide a short and direct response. 1.24. What is the ratio of the Revenue generated (in %) in Dominican Republic in 2004 to that in 2008?
Keep it short and to the point. 0.75. What is the ratio of the Revenue generated (in %) of Finland in 2004 to that in 2008?
Give a very brief answer. 1.08. What is the ratio of the Revenue generated (in %) in Sri Lanka in 2004 to that in 2008?
Provide a succinct answer. 1.34. What is the ratio of the Revenue generated (in %) in Dominican Republic in 2004 to that in 2009?
Ensure brevity in your answer.  0.75. What is the ratio of the Revenue generated (in %) of Lithuania in 2004 to that in 2009?
Provide a short and direct response. 1.02. What is the ratio of the Revenue generated (in %) in Sri Lanka in 2004 to that in 2009?
Ensure brevity in your answer.  1.59. What is the ratio of the Revenue generated (in %) in Dominican Republic in 2004 to that in 2010?
Ensure brevity in your answer.  0.76. What is the ratio of the Revenue generated (in %) of Finland in 2004 to that in 2010?
Your answer should be compact. 0.98. What is the ratio of the Revenue generated (in %) in Lithuania in 2004 to that in 2010?
Your response must be concise. 0.99. What is the ratio of the Revenue generated (in %) of Sri Lanka in 2004 to that in 2010?
Make the answer very short. 1.4. What is the ratio of the Revenue generated (in %) of Dominican Republic in 2005 to that in 2006?
Give a very brief answer. 0.89. What is the ratio of the Revenue generated (in %) in Finland in 2005 to that in 2006?
Provide a short and direct response. 1.01. What is the ratio of the Revenue generated (in %) of Lithuania in 2005 to that in 2006?
Give a very brief answer. 1.01. What is the ratio of the Revenue generated (in %) in Sri Lanka in 2005 to that in 2006?
Your answer should be very brief. 1.08. What is the ratio of the Revenue generated (in %) in Dominican Republic in 2005 to that in 2007?
Provide a short and direct response. 0.9. What is the ratio of the Revenue generated (in %) in Finland in 2005 to that in 2007?
Offer a very short reply. 1.06. What is the ratio of the Revenue generated (in %) of Lithuania in 2005 to that in 2007?
Your response must be concise. 0.98. What is the ratio of the Revenue generated (in %) in Sri Lanka in 2005 to that in 2007?
Ensure brevity in your answer.  1.15. What is the ratio of the Revenue generated (in %) in Dominican Republic in 2005 to that in 2008?
Ensure brevity in your answer.  0.87. What is the ratio of the Revenue generated (in %) of Finland in 2005 to that in 2008?
Provide a short and direct response. 1.06. What is the ratio of the Revenue generated (in %) in Lithuania in 2005 to that in 2008?
Your answer should be compact. 0.98. What is the ratio of the Revenue generated (in %) of Sri Lanka in 2005 to that in 2008?
Make the answer very short. 1.24. What is the ratio of the Revenue generated (in %) in Dominican Republic in 2005 to that in 2009?
Provide a succinct answer. 0.88. What is the ratio of the Revenue generated (in %) in Finland in 2005 to that in 2009?
Provide a short and direct response. 0.98. What is the ratio of the Revenue generated (in %) of Lithuania in 2005 to that in 2009?
Provide a succinct answer. 1.01. What is the ratio of the Revenue generated (in %) in Sri Lanka in 2005 to that in 2009?
Give a very brief answer. 1.47. What is the ratio of the Revenue generated (in %) in Dominican Republic in 2005 to that in 2010?
Your answer should be compact. 0.88. What is the ratio of the Revenue generated (in %) in Finland in 2005 to that in 2010?
Give a very brief answer. 0.97. What is the ratio of the Revenue generated (in %) of Lithuania in 2005 to that in 2010?
Provide a succinct answer. 0.97. What is the ratio of the Revenue generated (in %) of Sri Lanka in 2005 to that in 2010?
Your answer should be very brief. 1.3. What is the ratio of the Revenue generated (in %) in Dominican Republic in 2006 to that in 2007?
Provide a succinct answer. 1.01. What is the ratio of the Revenue generated (in %) in Finland in 2006 to that in 2007?
Your answer should be very brief. 1.04. What is the ratio of the Revenue generated (in %) in Lithuania in 2006 to that in 2007?
Your answer should be compact. 0.97. What is the ratio of the Revenue generated (in %) in Sri Lanka in 2006 to that in 2007?
Give a very brief answer. 1.06. What is the ratio of the Revenue generated (in %) of Dominican Republic in 2006 to that in 2008?
Make the answer very short. 0.98. What is the ratio of the Revenue generated (in %) in Finland in 2006 to that in 2008?
Ensure brevity in your answer.  1.05. What is the ratio of the Revenue generated (in %) in Lithuania in 2006 to that in 2008?
Your answer should be very brief. 0.97. What is the ratio of the Revenue generated (in %) of Sri Lanka in 2006 to that in 2008?
Give a very brief answer. 1.15. What is the ratio of the Revenue generated (in %) of Dominican Republic in 2006 to that in 2009?
Ensure brevity in your answer.  0.99. What is the ratio of the Revenue generated (in %) of Finland in 2006 to that in 2009?
Give a very brief answer. 0.97. What is the ratio of the Revenue generated (in %) of Sri Lanka in 2006 to that in 2009?
Keep it short and to the point. 1.36. What is the ratio of the Revenue generated (in %) of Dominican Republic in 2006 to that in 2010?
Offer a very short reply. 0.99. What is the ratio of the Revenue generated (in %) of Finland in 2006 to that in 2010?
Your answer should be compact. 0.95. What is the ratio of the Revenue generated (in %) of Lithuania in 2006 to that in 2010?
Provide a short and direct response. 0.96. What is the ratio of the Revenue generated (in %) of Sri Lanka in 2006 to that in 2010?
Give a very brief answer. 1.2. What is the ratio of the Revenue generated (in %) in Dominican Republic in 2007 to that in 2008?
Offer a very short reply. 0.97. What is the ratio of the Revenue generated (in %) in Finland in 2007 to that in 2008?
Provide a short and direct response. 1.01. What is the ratio of the Revenue generated (in %) of Sri Lanka in 2007 to that in 2008?
Ensure brevity in your answer.  1.08. What is the ratio of the Revenue generated (in %) of Dominican Republic in 2007 to that in 2009?
Your answer should be compact. 0.98. What is the ratio of the Revenue generated (in %) of Finland in 2007 to that in 2009?
Your response must be concise. 0.93. What is the ratio of the Revenue generated (in %) in Lithuania in 2007 to that in 2009?
Your response must be concise. 1.03. What is the ratio of the Revenue generated (in %) of Sri Lanka in 2007 to that in 2009?
Your answer should be very brief. 1.28. What is the ratio of the Revenue generated (in %) of Dominican Republic in 2007 to that in 2010?
Offer a very short reply. 0.98. What is the ratio of the Revenue generated (in %) in Finland in 2007 to that in 2010?
Your answer should be very brief. 0.92. What is the ratio of the Revenue generated (in %) of Lithuania in 2007 to that in 2010?
Provide a short and direct response. 0.99. What is the ratio of the Revenue generated (in %) of Sri Lanka in 2007 to that in 2010?
Give a very brief answer. 1.13. What is the ratio of the Revenue generated (in %) of Dominican Republic in 2008 to that in 2009?
Keep it short and to the point. 1.01. What is the ratio of the Revenue generated (in %) in Finland in 2008 to that in 2009?
Keep it short and to the point. 0.92. What is the ratio of the Revenue generated (in %) of Lithuania in 2008 to that in 2009?
Offer a terse response. 1.03. What is the ratio of the Revenue generated (in %) in Sri Lanka in 2008 to that in 2009?
Give a very brief answer. 1.19. What is the ratio of the Revenue generated (in %) of Dominican Republic in 2008 to that in 2010?
Ensure brevity in your answer.  1.01. What is the ratio of the Revenue generated (in %) in Finland in 2008 to that in 2010?
Your answer should be very brief. 0.91. What is the ratio of the Revenue generated (in %) of Sri Lanka in 2008 to that in 2010?
Keep it short and to the point. 1.05. What is the ratio of the Revenue generated (in %) in Finland in 2009 to that in 2010?
Keep it short and to the point. 0.98. What is the ratio of the Revenue generated (in %) in Lithuania in 2009 to that in 2010?
Ensure brevity in your answer.  0.97. What is the ratio of the Revenue generated (in %) of Sri Lanka in 2009 to that in 2010?
Provide a short and direct response. 0.88. What is the difference between the highest and the second highest Revenue generated (in %) in Dominican Republic?
Make the answer very short. 0.3. What is the difference between the highest and the second highest Revenue generated (in %) in Finland?
Offer a terse response. 0.54. What is the difference between the highest and the second highest Revenue generated (in %) in Lithuania?
Provide a short and direct response. 0.24. What is the difference between the highest and the second highest Revenue generated (in %) in Sri Lanka?
Make the answer very short. 4.56. What is the difference between the highest and the lowest Revenue generated (in %) in Dominican Republic?
Keep it short and to the point. 13.38. What is the difference between the highest and the lowest Revenue generated (in %) in Finland?
Ensure brevity in your answer.  3.2. What is the difference between the highest and the lowest Revenue generated (in %) of Lithuania?
Provide a succinct answer. 1.31. What is the difference between the highest and the lowest Revenue generated (in %) in Sri Lanka?
Offer a very short reply. 22.3. 